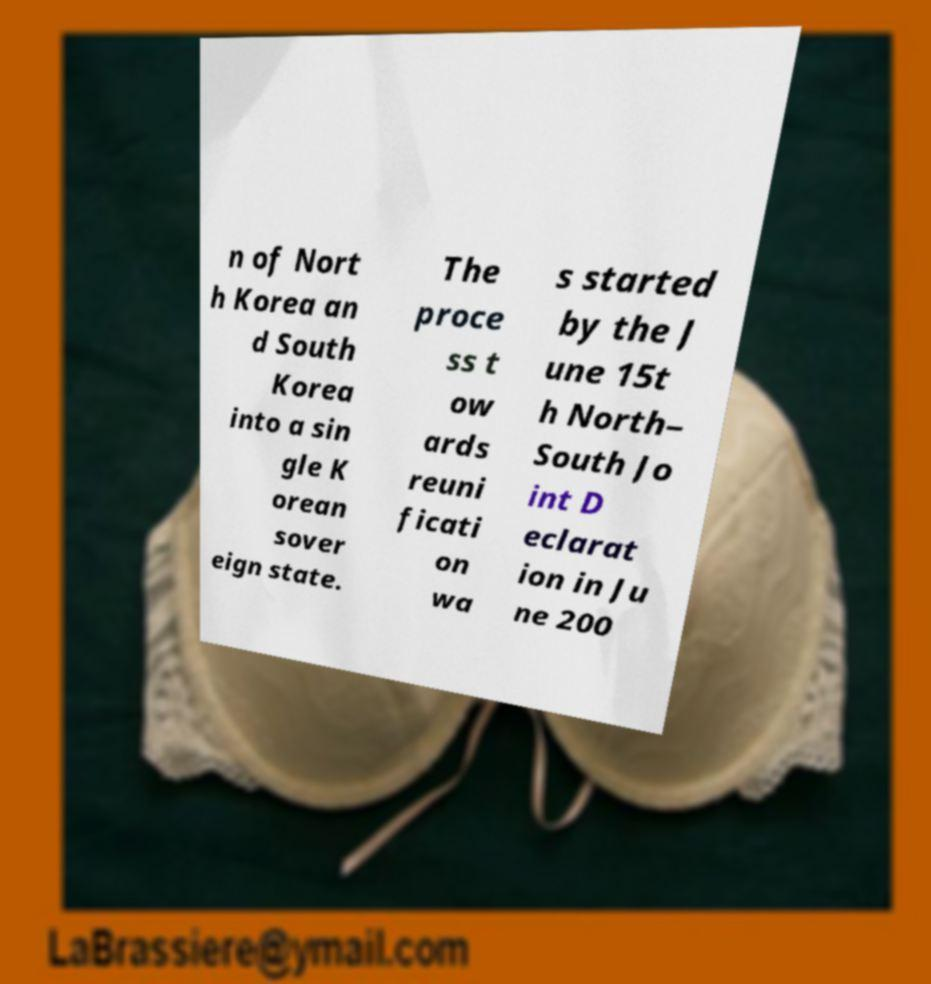Can you read and provide the text displayed in the image?This photo seems to have some interesting text. Can you extract and type it out for me? n of Nort h Korea an d South Korea into a sin gle K orean sover eign state. The proce ss t ow ards reuni ficati on wa s started by the J une 15t h North– South Jo int D eclarat ion in Ju ne 200 